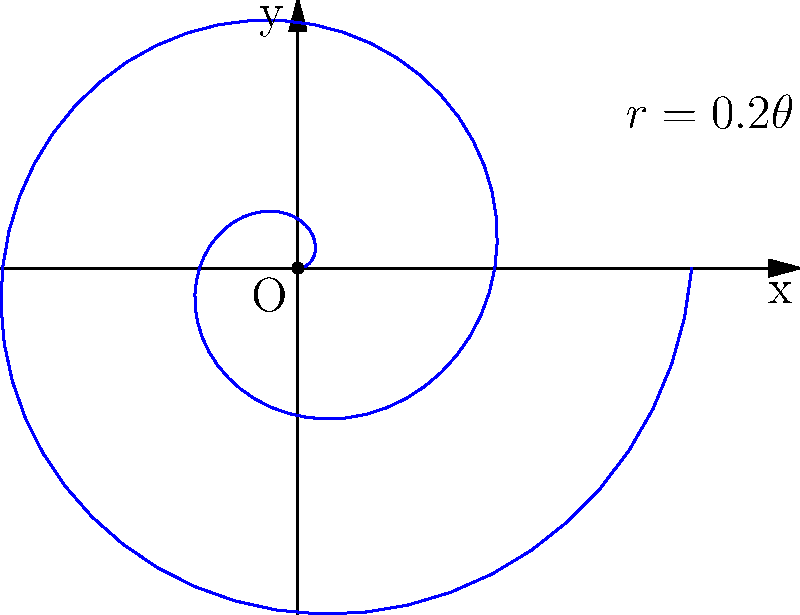In our tribe's sacred garden, we're planning a spiral-shaped herb plot. The spiral follows the equation $r=0.2\theta$ in polar coordinates, where $r$ is in meters and $\theta$ is in radians. If we want the spiral to make two complete revolutions, what will be the total area of our herb garden in square meters? To find the area of the spiral-shaped herb garden, we'll use polar integration. Here's how we'll approach this:

1) The formula for the area of a region in polar coordinates is:

   $$A = \frac{1}{2} \int_a^b r^2(\theta) d\theta$$

2) We're given that $r=0.2\theta$. Let's substitute this into our formula:

   $$A = \frac{1}{2} \int_a^b (0.2\theta)^2 d\theta$$

3) Simplify the integrand:

   $$A = \frac{1}{2} \int_a^b 0.04\theta^2 d\theta$$

4) For two complete revolutions, $\theta$ goes from 0 to $4\pi$. These are our limits of integration:

   $$A = \frac{1}{2} \int_0^{4\pi} 0.04\theta^2 d\theta$$

5) Now let's integrate:

   $$A = \frac{1}{2} \cdot 0.04 \cdot \frac{\theta^3}{3} \bigg|_0^{4\pi}$$

6) Evaluate the integral:

   $$A = 0.02 \cdot \frac{(4\pi)^3}{3} - 0.02 \cdot \frac{0^3}{3}$$

7) Simplify:

   $$A = 0.02 \cdot \frac{64\pi^3}{3} = \frac{64\pi^3}{150} \approx 8.39 \text{ square meters}$$

Thus, the total area of our spiral herb garden will be approximately 8.39 square meters.
Answer: $\frac{64\pi^3}{150}$ m² (≈ 8.39 m²) 